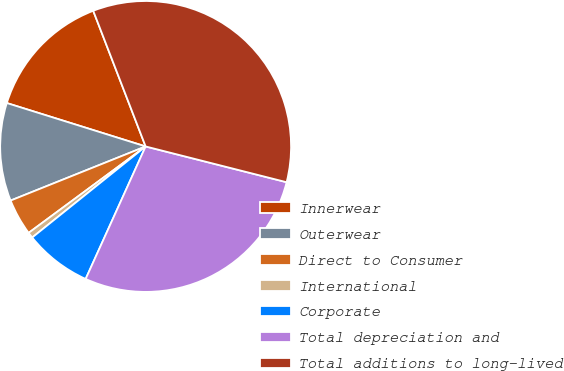Convert chart. <chart><loc_0><loc_0><loc_500><loc_500><pie_chart><fcel>Innerwear<fcel>Outerwear<fcel>Direct to Consumer<fcel>International<fcel>Corporate<fcel>Total depreciation and<fcel>Total additions to long-lived<nl><fcel>14.31%<fcel>10.89%<fcel>4.06%<fcel>0.64%<fcel>7.47%<fcel>27.81%<fcel>34.82%<nl></chart> 